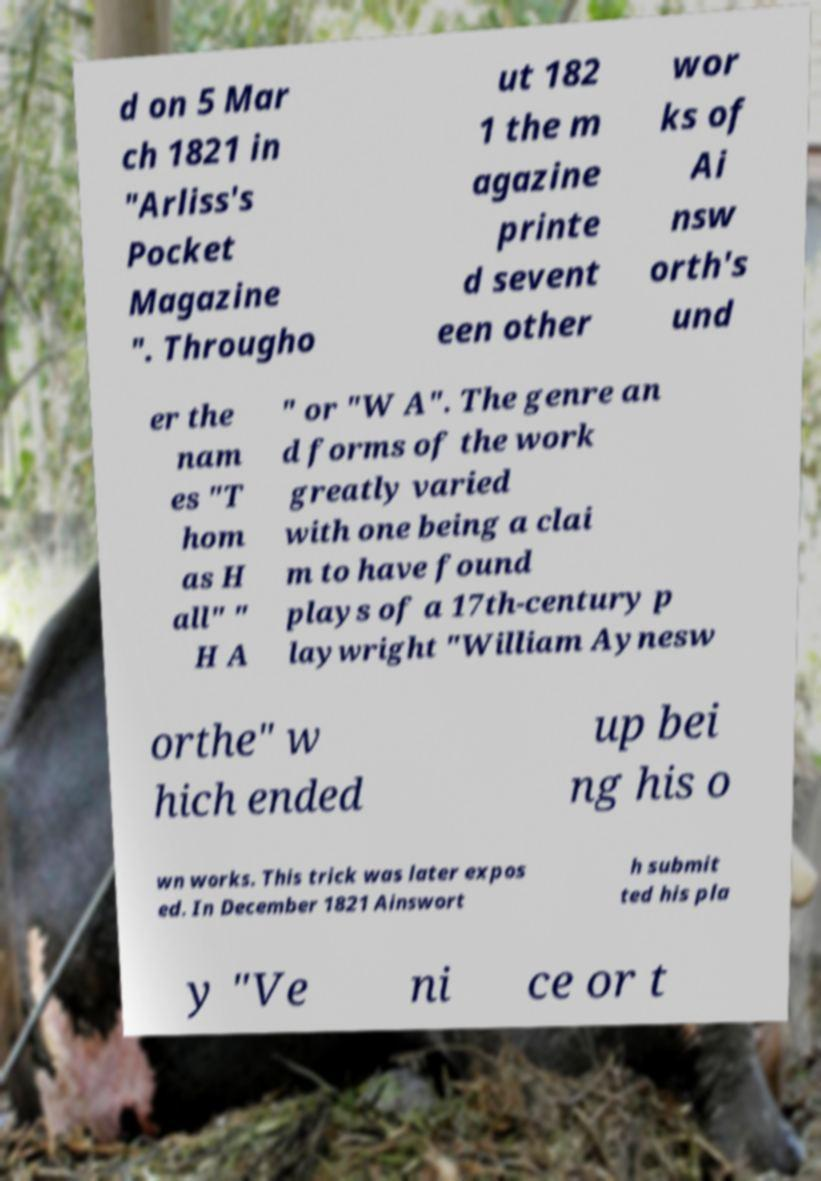For documentation purposes, I need the text within this image transcribed. Could you provide that? d on 5 Mar ch 1821 in "Arliss's Pocket Magazine ". Througho ut 182 1 the m agazine printe d sevent een other wor ks of Ai nsw orth's und er the nam es "T hom as H all" " H A " or "W A". The genre an d forms of the work greatly varied with one being a clai m to have found plays of a 17th-century p laywright "William Aynesw orthe" w hich ended up bei ng his o wn works. This trick was later expos ed. In December 1821 Ainswort h submit ted his pla y "Ve ni ce or t 